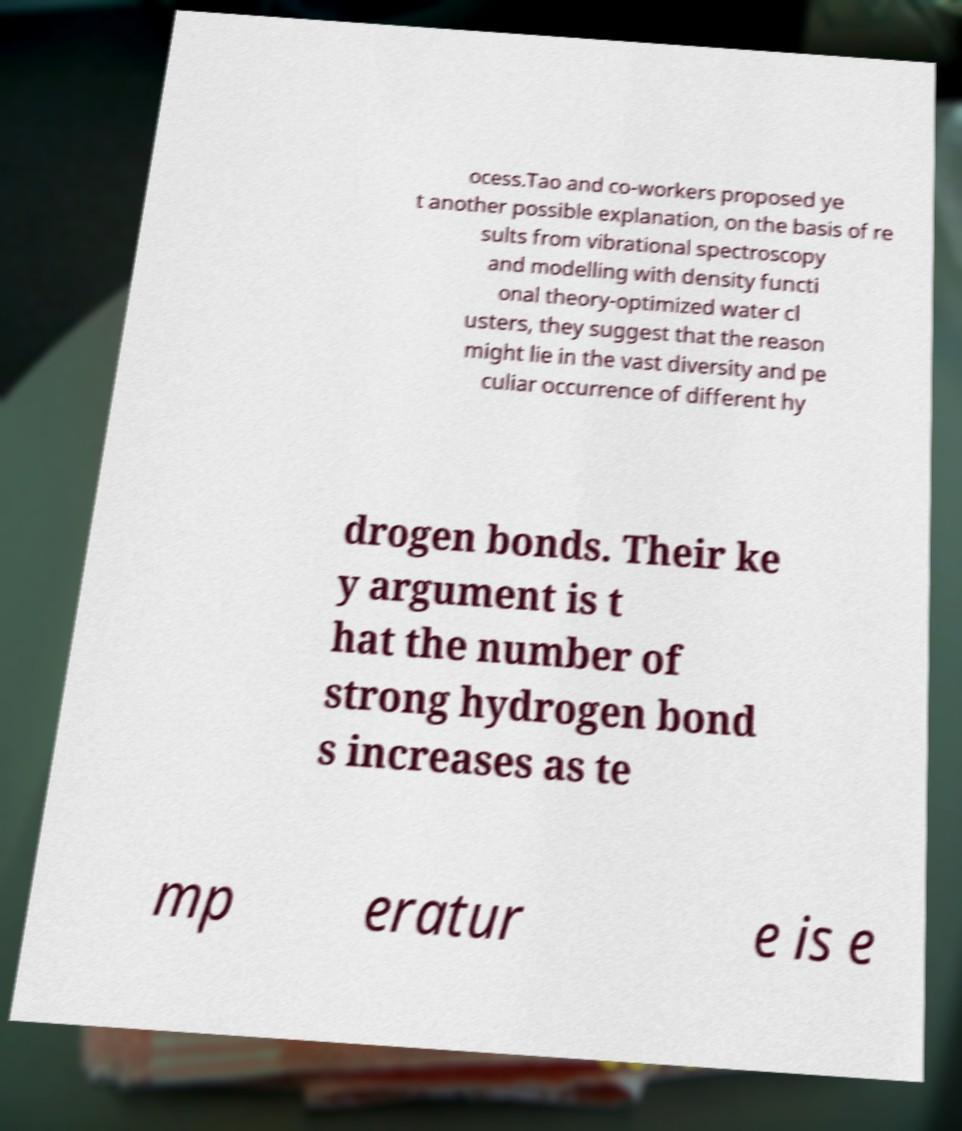I need the written content from this picture converted into text. Can you do that? ocess.Tao and co-workers proposed ye t another possible explanation, on the basis of re sults from vibrational spectroscopy and modelling with density functi onal theory-optimized water cl usters, they suggest that the reason might lie in the vast diversity and pe culiar occurrence of different hy drogen bonds. Their ke y argument is t hat the number of strong hydrogen bond s increases as te mp eratur e is e 